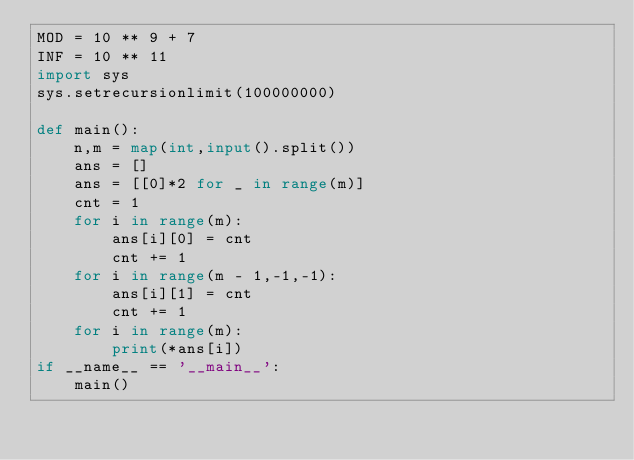Convert code to text. <code><loc_0><loc_0><loc_500><loc_500><_Python_>MOD = 10 ** 9 + 7
INF = 10 ** 11
import sys
sys.setrecursionlimit(100000000)

def main():
    n,m = map(int,input().split())
    ans = []
    ans = [[0]*2 for _ in range(m)]
    cnt = 1
    for i in range(m):
        ans[i][0] = cnt
        cnt += 1
    for i in range(m - 1,-1,-1):
        ans[i][1] = cnt
        cnt += 1
    for i in range(m):
        print(*ans[i])
if __name__ == '__main__':
    main()
</code> 